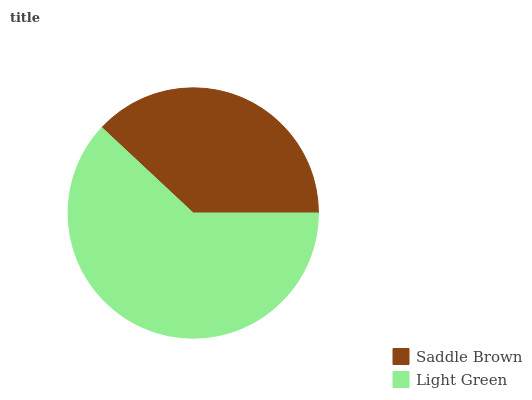Is Saddle Brown the minimum?
Answer yes or no. Yes. Is Light Green the maximum?
Answer yes or no. Yes. Is Light Green the minimum?
Answer yes or no. No. Is Light Green greater than Saddle Brown?
Answer yes or no. Yes. Is Saddle Brown less than Light Green?
Answer yes or no. Yes. Is Saddle Brown greater than Light Green?
Answer yes or no. No. Is Light Green less than Saddle Brown?
Answer yes or no. No. Is Light Green the high median?
Answer yes or no. Yes. Is Saddle Brown the low median?
Answer yes or no. Yes. Is Saddle Brown the high median?
Answer yes or no. No. Is Light Green the low median?
Answer yes or no. No. 